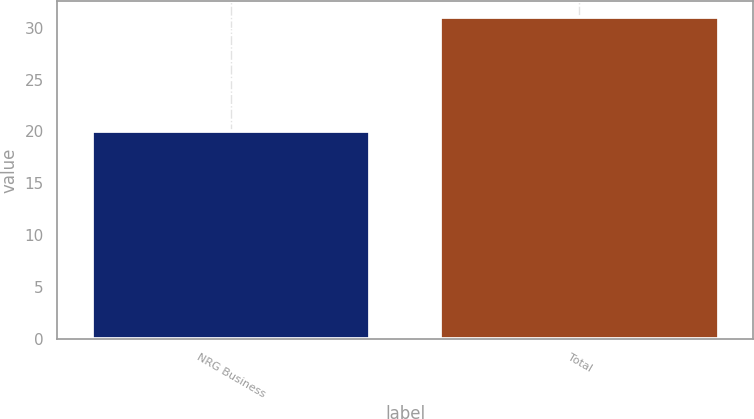<chart> <loc_0><loc_0><loc_500><loc_500><bar_chart><fcel>NRG Business<fcel>Total<nl><fcel>20<fcel>31<nl></chart> 